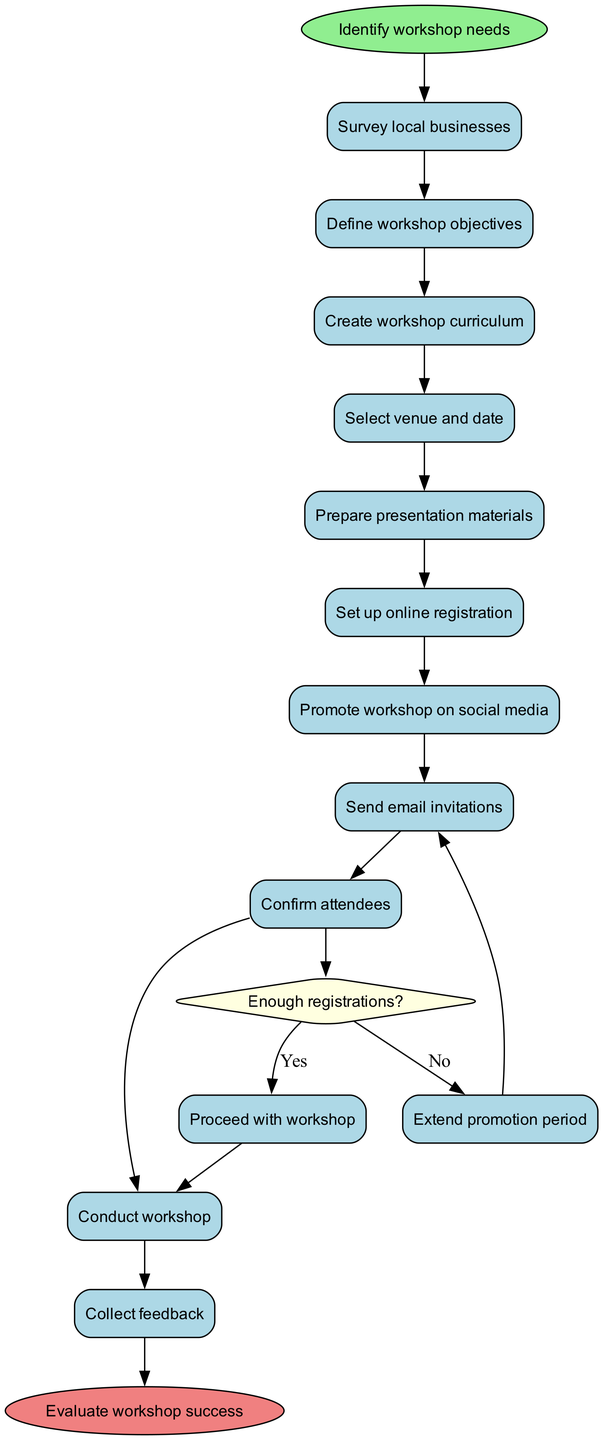What is the first activity in the diagram? The diagram begins with the 'Identify workshop needs' node, marking the starting point of the process. Therefore, the first activity listed is that one.
Answer: Identify workshop needs How many activities are shown in the diagram? The diagram lists 11 activities in total, from 'Survey local businesses' to 'Collect feedback'. I counted them in the activities section of the diagram.
Answer: 11 What is the decision question in the diagram? The decision made in the diagram revolves around the question 'Enough registrations?'. This is the only decision point in the workflow, which determines the next steps based on the answer.
Answer: Enough registrations? Which activity leads to the decision point? The activity 'Promote workshop on social media' connects directly to the decision question 'Enough registrations?'. It is the last activity before a decision is made.
Answer: Promote workshop on social media What happens if there are not enough registrations? If there are not enough registrations, the flow directs to 'Extend promotion period', which indicates the action taken when the answer to the decision is 'No'.
Answer: Extend promotion period How does the process end? The process concludes with the activity 'Evaluate workshop success', which follows the final activity of 'Conduct workshop' in the workflow.
Answer: Evaluate workshop success What is the relationship between 'Send email invitations' and 'Confirm attendees'? There is a direct sequence relationship where 'Send email invitations' precedes 'Confirm attendees' in the process flow. This indicates that confirmations cannot happen before invitations are sent.
Answer: Send email invitations → Confirm attendees What is the last activity before evaluating the workshop? The last activity executed before reaching the evaluation is 'Collect feedback', as it directly comes before the end node that indicates the workshop's success evaluation.
Answer: Collect feedback What is the purpose of 'Prepare presentation materials'? The purpose of 'Prepare presentation materials' is to ensure that all necessary content and tools are ready for the workshop, making it a crucial part of the curriculum development process.
Answer: Workshop preparation 